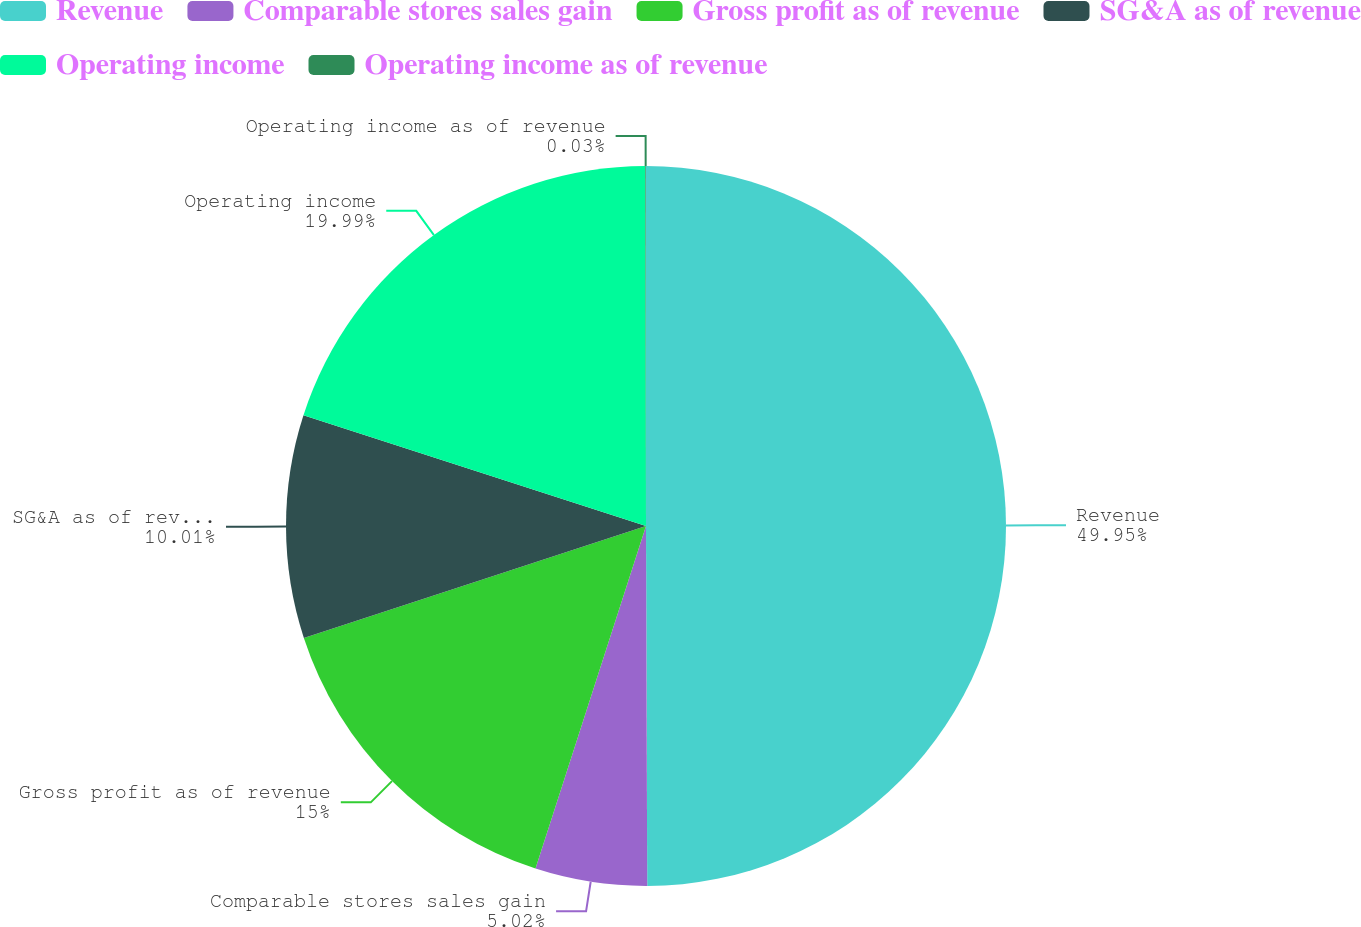Convert chart to OTSL. <chart><loc_0><loc_0><loc_500><loc_500><pie_chart><fcel>Revenue<fcel>Comparable stores sales gain<fcel>Gross profit as of revenue<fcel>SG&A as of revenue<fcel>Operating income<fcel>Operating income as of revenue<nl><fcel>49.94%<fcel>5.02%<fcel>15.0%<fcel>10.01%<fcel>19.99%<fcel>0.03%<nl></chart> 